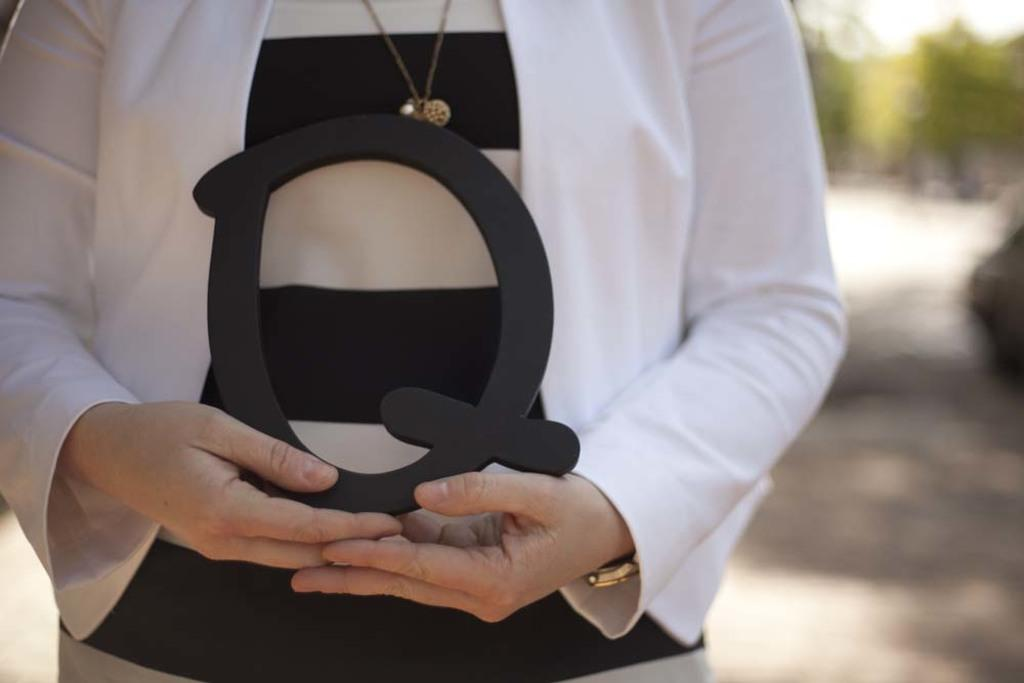What is the main subject of the image? There is a person in the image. What is the person holding in the image? The person is holding a black object. Can you describe the person's clothing in the image? The person is wearing a black and white dress. How would you describe the background of the image? The background of the image is blurred. What is the rate of the jar in the image? There is no jar present in the image, so it is not possible to determine a rate. 